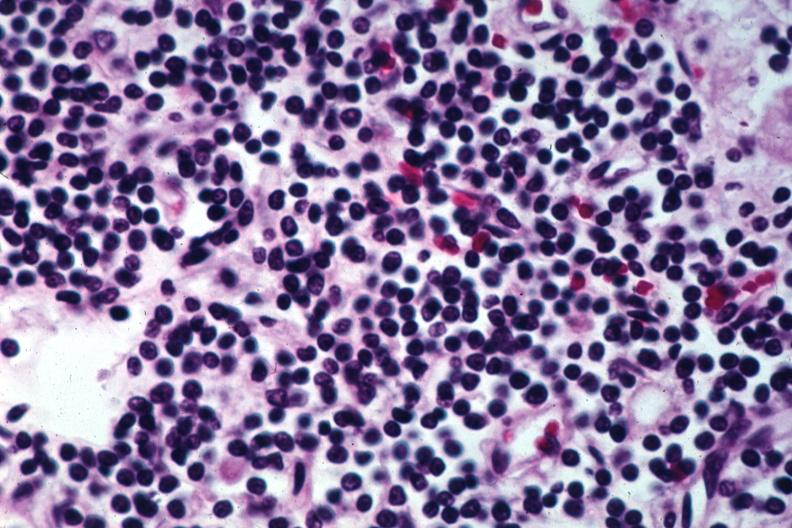where is this?
Answer the question using a single word or phrase. Skin 